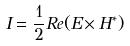<formula> <loc_0><loc_0><loc_500><loc_500>I = \frac { 1 } { 2 } R e ( E \times H ^ { * } )</formula> 